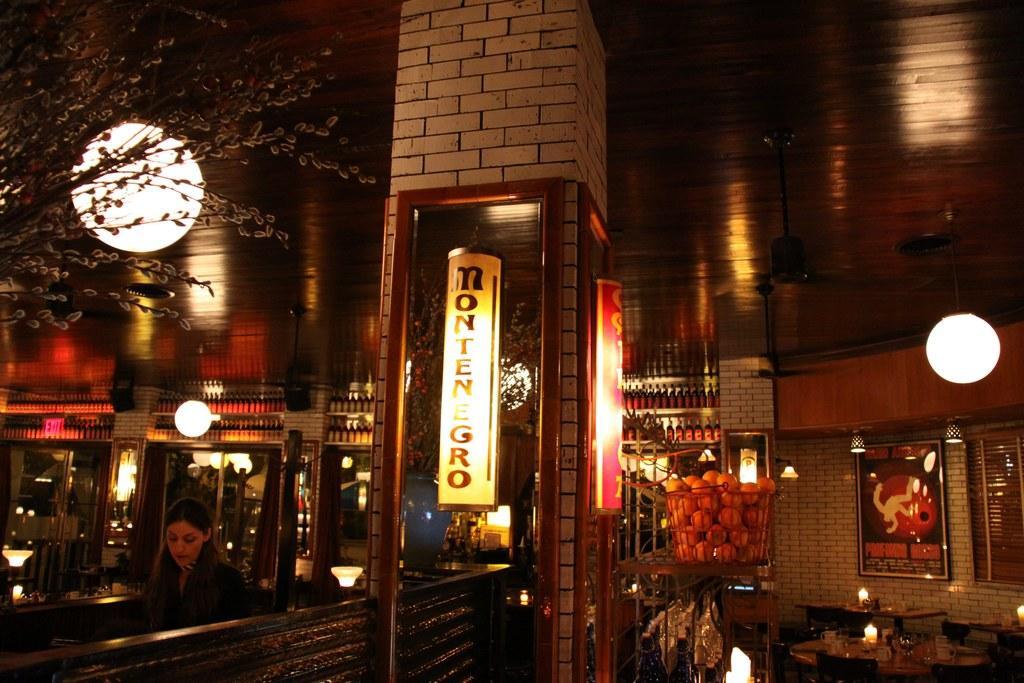Can you describe this image briefly? In this image we can see a woman, a basket with the fruits. We can see the tables, chairs, candles, mirrors, pillar, lights, flower vase and also the frames attached to the wall. We can also see the ceiling. 